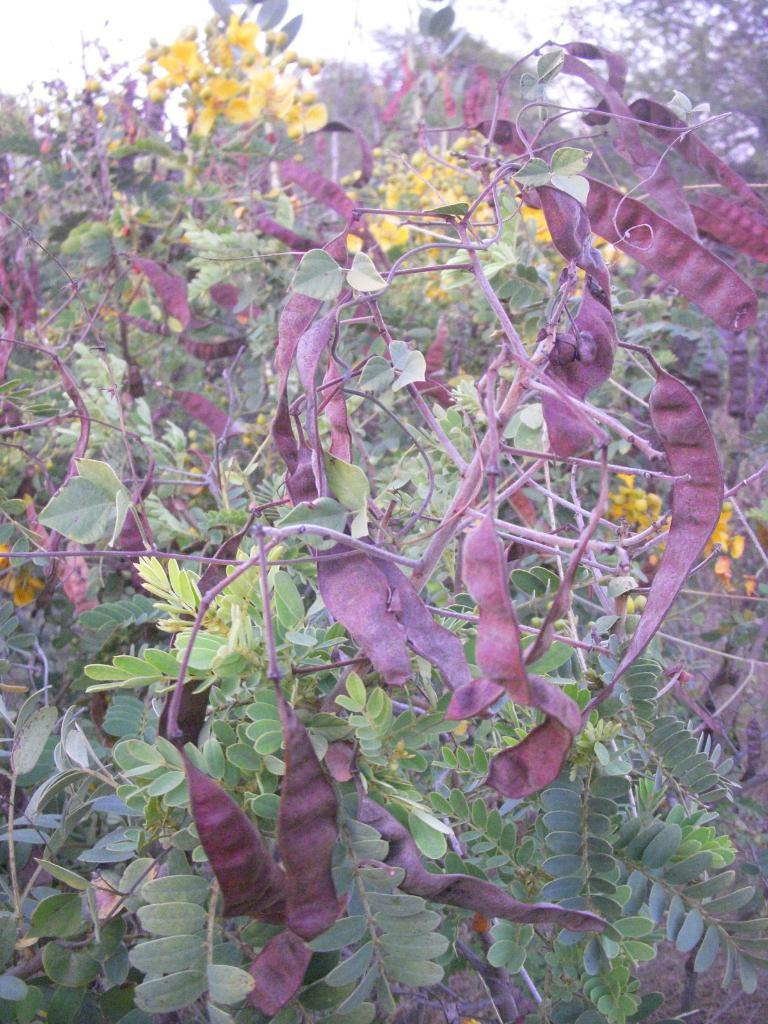What type of living organisms can be seen in the image? Plants can be seen in the image. What color are the flowers on the plants? The flowers on the plants are yellow. What stage of development is the plant's mind in the image? Plants do not have minds, so this question cannot be answered. 